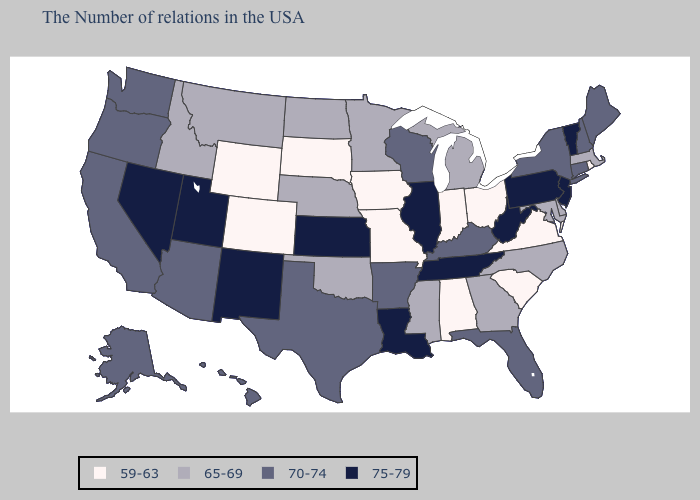Name the states that have a value in the range 70-74?
Quick response, please. Maine, New Hampshire, Connecticut, New York, Florida, Kentucky, Wisconsin, Arkansas, Texas, Arizona, California, Washington, Oregon, Alaska, Hawaii. Does Montana have the highest value in the West?
Quick response, please. No. Name the states that have a value in the range 75-79?
Concise answer only. Vermont, New Jersey, Pennsylvania, West Virginia, Tennessee, Illinois, Louisiana, Kansas, New Mexico, Utah, Nevada. What is the value of Arizona?
Give a very brief answer. 70-74. Does Florida have the same value as Massachusetts?
Concise answer only. No. Is the legend a continuous bar?
Be succinct. No. What is the value of North Dakota?
Answer briefly. 65-69. Does Connecticut have a higher value than New Jersey?
Write a very short answer. No. What is the highest value in the USA?
Be succinct. 75-79. What is the highest value in the USA?
Write a very short answer. 75-79. Which states have the highest value in the USA?
Keep it brief. Vermont, New Jersey, Pennsylvania, West Virginia, Tennessee, Illinois, Louisiana, Kansas, New Mexico, Utah, Nevada. What is the value of Connecticut?
Be succinct. 70-74. What is the value of Massachusetts?
Give a very brief answer. 65-69. Name the states that have a value in the range 65-69?
Keep it brief. Massachusetts, Delaware, Maryland, North Carolina, Georgia, Michigan, Mississippi, Minnesota, Nebraska, Oklahoma, North Dakota, Montana, Idaho. What is the value of Oregon?
Quick response, please. 70-74. 